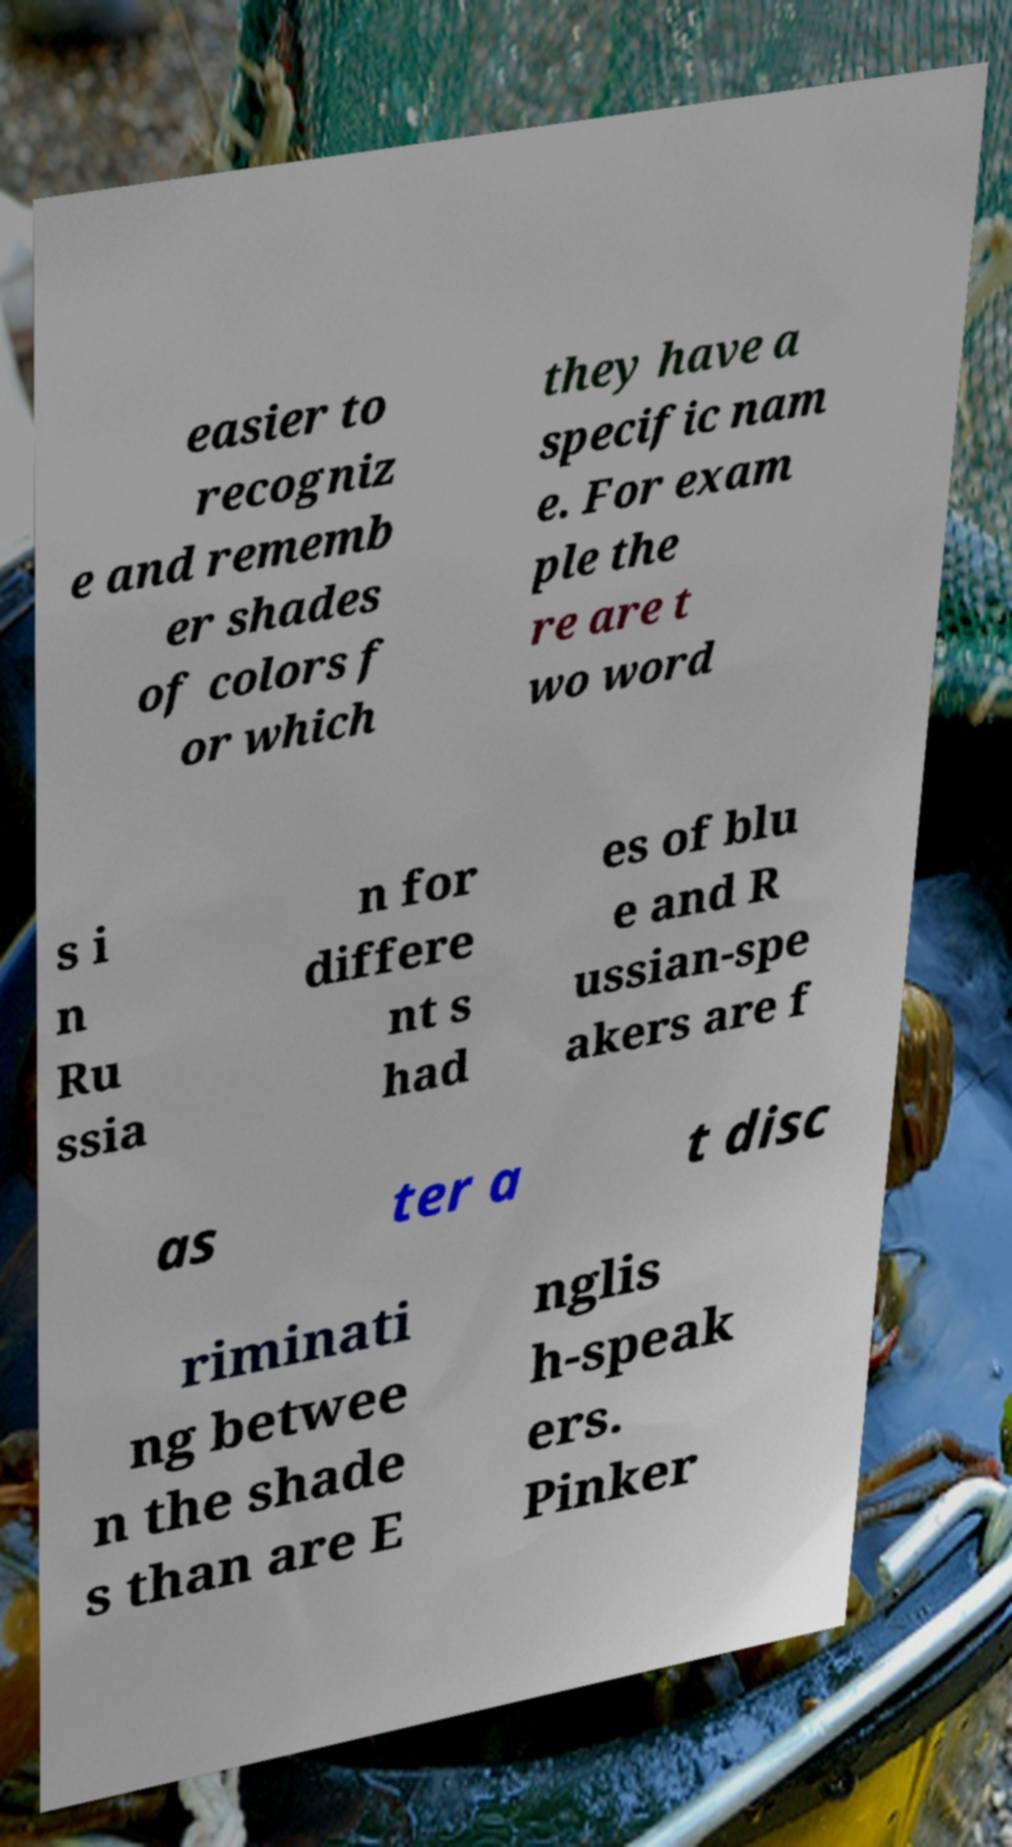I need the written content from this picture converted into text. Can you do that? easier to recogniz e and rememb er shades of colors f or which they have a specific nam e. For exam ple the re are t wo word s i n Ru ssia n for differe nt s had es of blu e and R ussian-spe akers are f as ter a t disc riminati ng betwee n the shade s than are E nglis h-speak ers. Pinker 